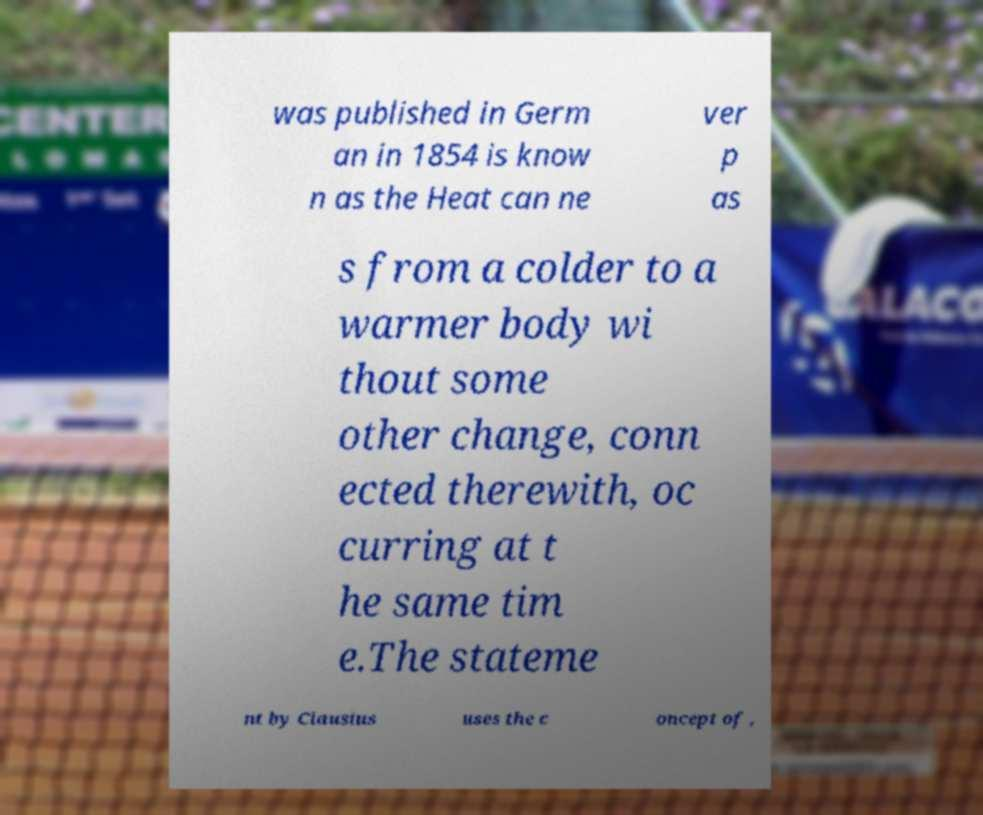Can you accurately transcribe the text from the provided image for me? was published in Germ an in 1854 is know n as the Heat can ne ver p as s from a colder to a warmer body wi thout some other change, conn ected therewith, oc curring at t he same tim e.The stateme nt by Clausius uses the c oncept of , 